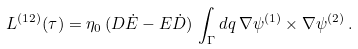Convert formula to latex. <formula><loc_0><loc_0><loc_500><loc_500>L ^ { ( 1 2 ) } ( \tau ) = \eta _ { 0 } \, ( D \dot { E } - E \dot { D } ) \, \int _ { \Gamma } d q \, \nabla \psi ^ { ( 1 ) } \times \nabla \psi ^ { ( 2 ) } \, .</formula> 